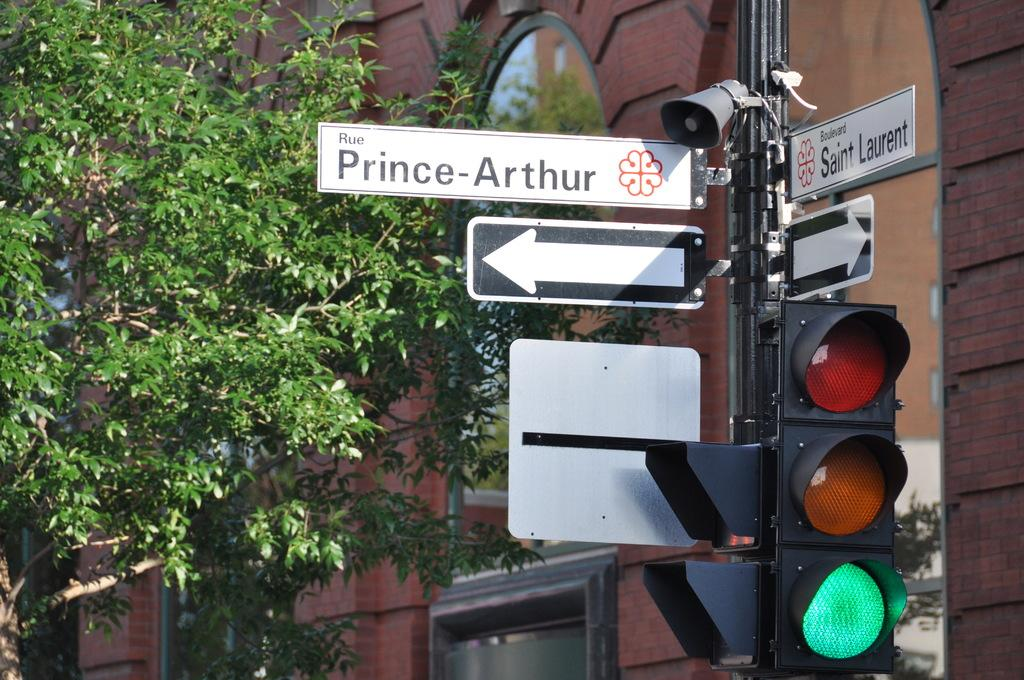<image>
Give a short and clear explanation of the subsequent image. A street sign for Rue Prince-Arthur is just above an arrow pointing to the left. 